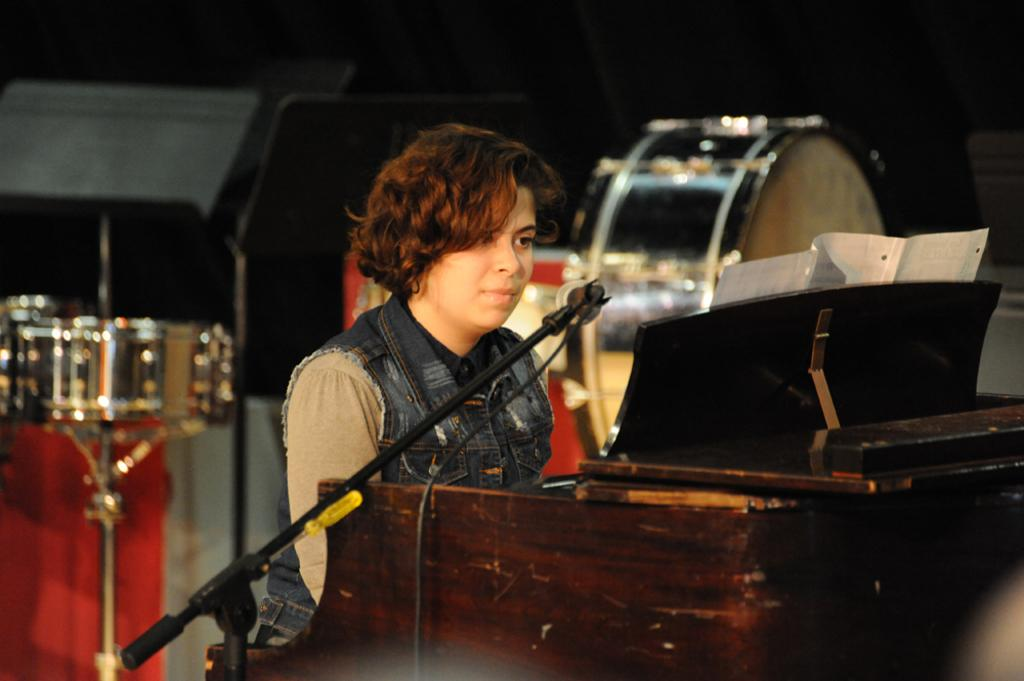Who is the main subject in the picture? There is a woman in the picture. What is the woman doing in the image? The woman is sitting on a chair and is in front of a microphone. What can be seen in the background of the image? There are musical instruments in the background, including drums. Can you describe the woman's hair in the image? The woman has curly hair. What type of vessel is the woman using to teach in the image? There is no vessel present in the image, and the woman is not teaching. What kind of horn can be seen on the woman's head in the image? There is no horn on the woman's head in the image; she has curly hair. 